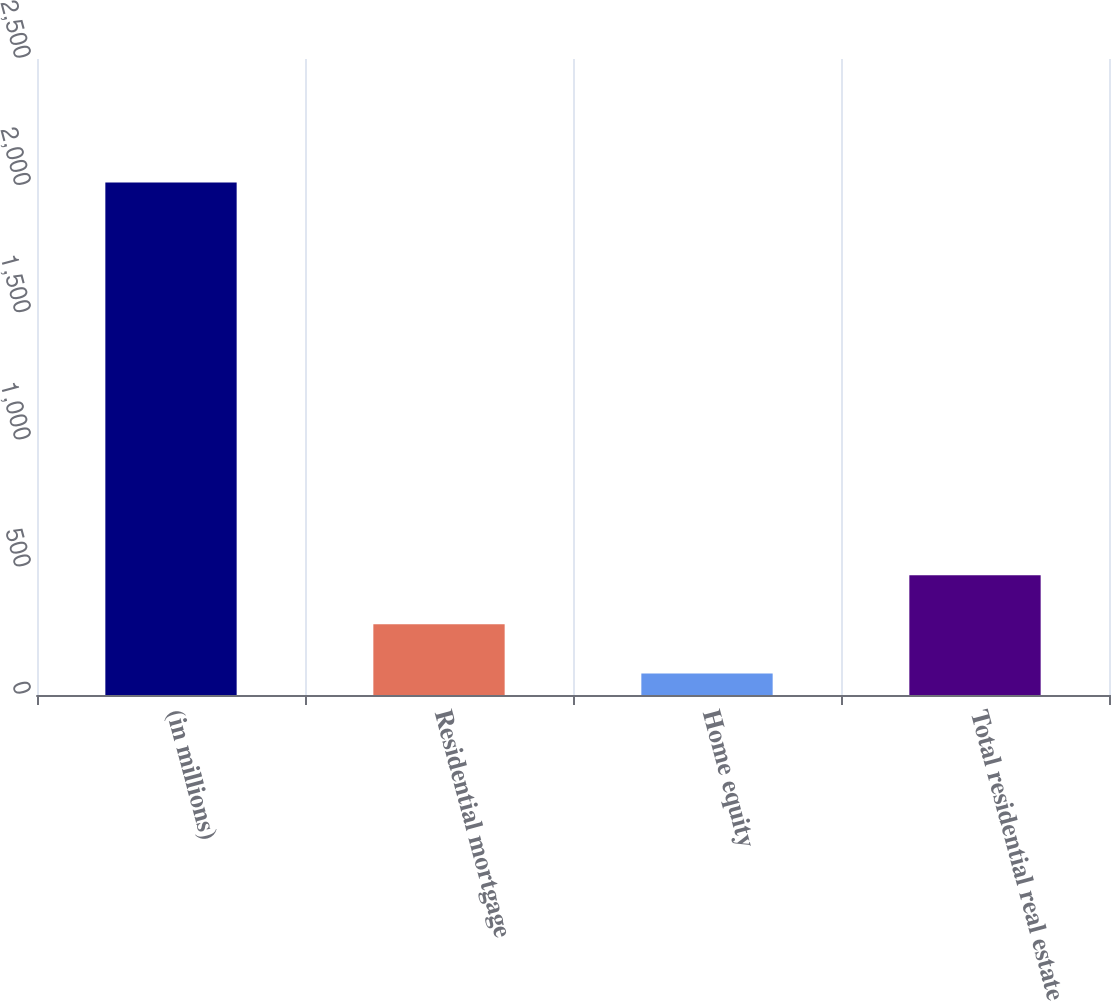Convert chart. <chart><loc_0><loc_0><loc_500><loc_500><bar_chart><fcel>(in millions)<fcel>Residential mortgage<fcel>Home equity<fcel>Total residential real estate<nl><fcel>2015<fcel>278<fcel>85<fcel>471<nl></chart> 